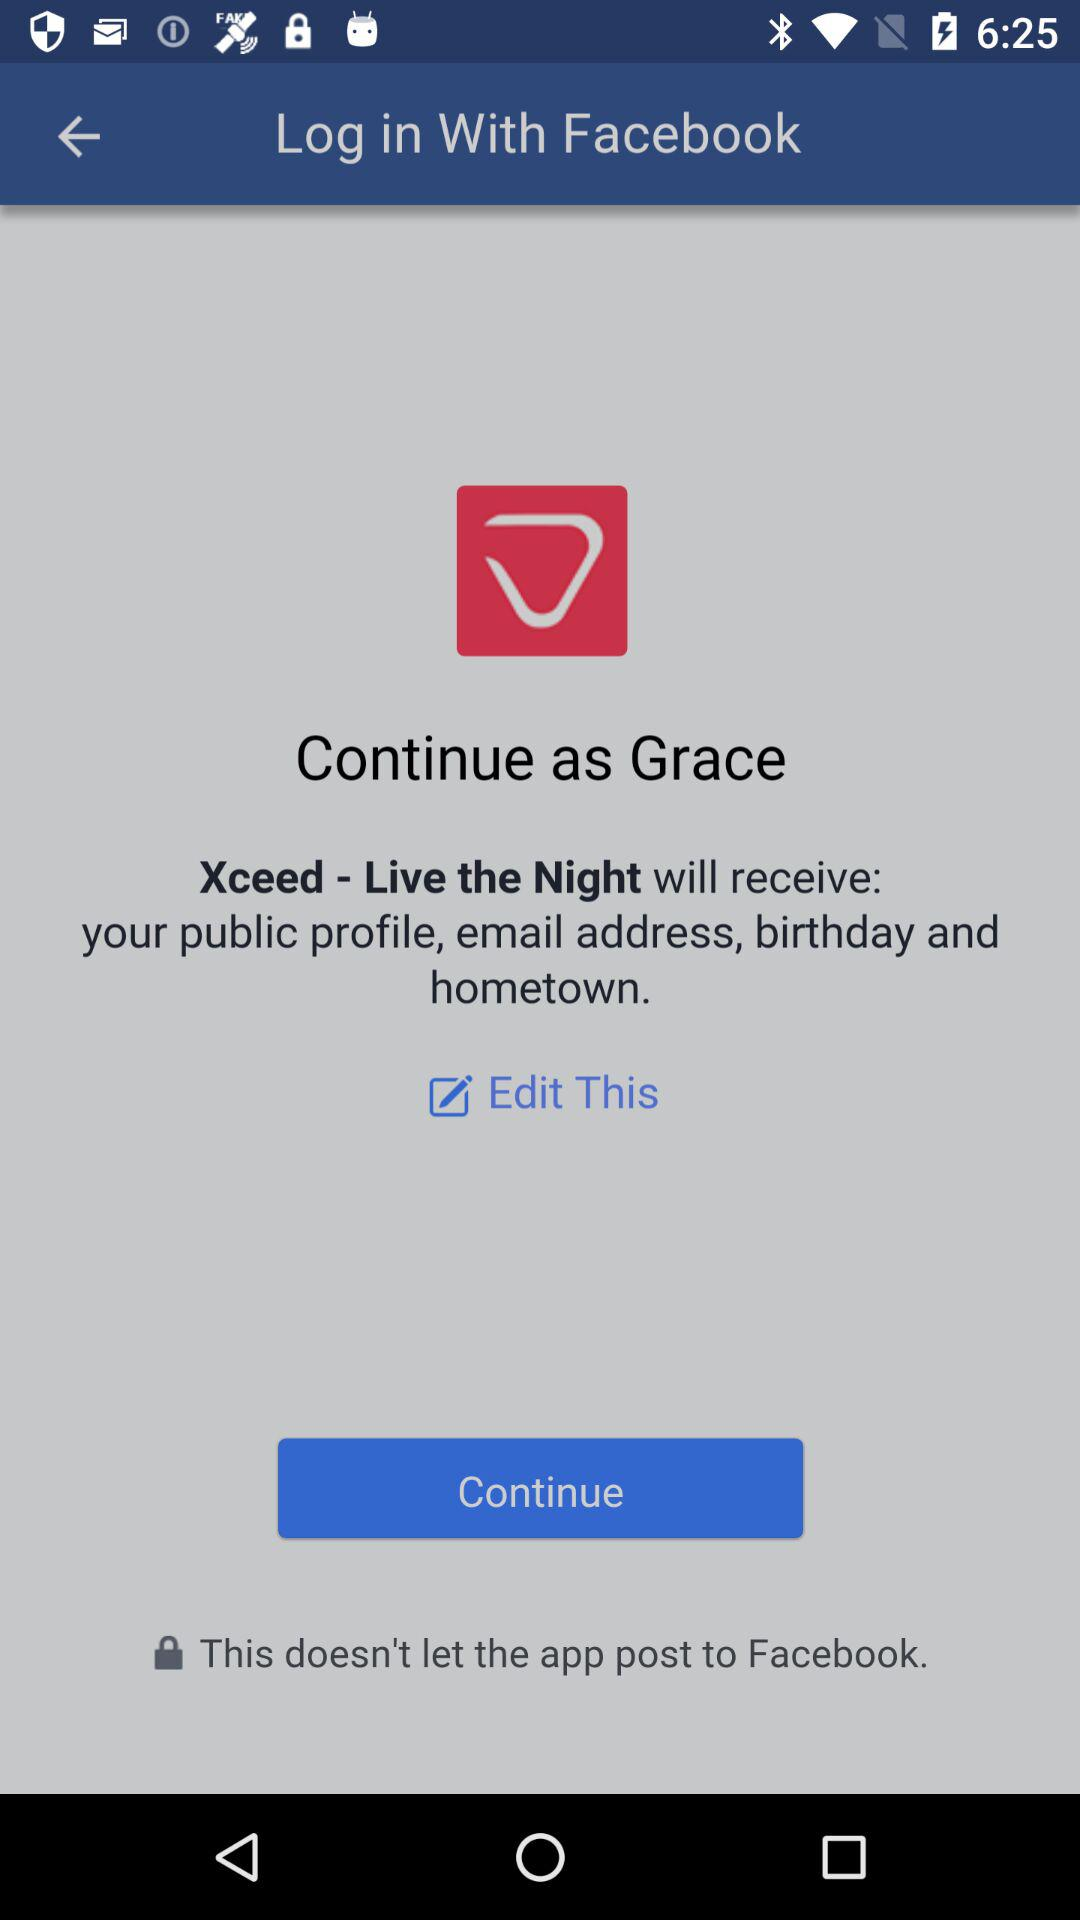What information will "Xceed-Live the Night" receive? "Xceed-Live the Night" will receive your public profile, email address, birthday, and hometown. 